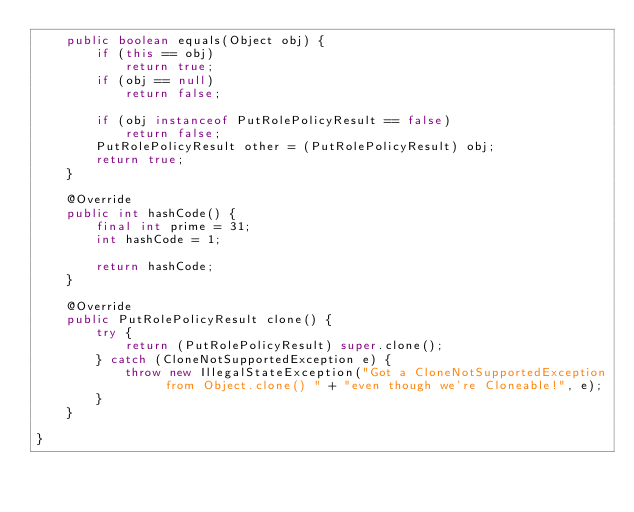Convert code to text. <code><loc_0><loc_0><loc_500><loc_500><_Java_>    public boolean equals(Object obj) {
        if (this == obj)
            return true;
        if (obj == null)
            return false;

        if (obj instanceof PutRolePolicyResult == false)
            return false;
        PutRolePolicyResult other = (PutRolePolicyResult) obj;
        return true;
    }

    @Override
    public int hashCode() {
        final int prime = 31;
        int hashCode = 1;

        return hashCode;
    }

    @Override
    public PutRolePolicyResult clone() {
        try {
            return (PutRolePolicyResult) super.clone();
        } catch (CloneNotSupportedException e) {
            throw new IllegalStateException("Got a CloneNotSupportedException from Object.clone() " + "even though we're Cloneable!", e);
        }
    }

}
</code> 